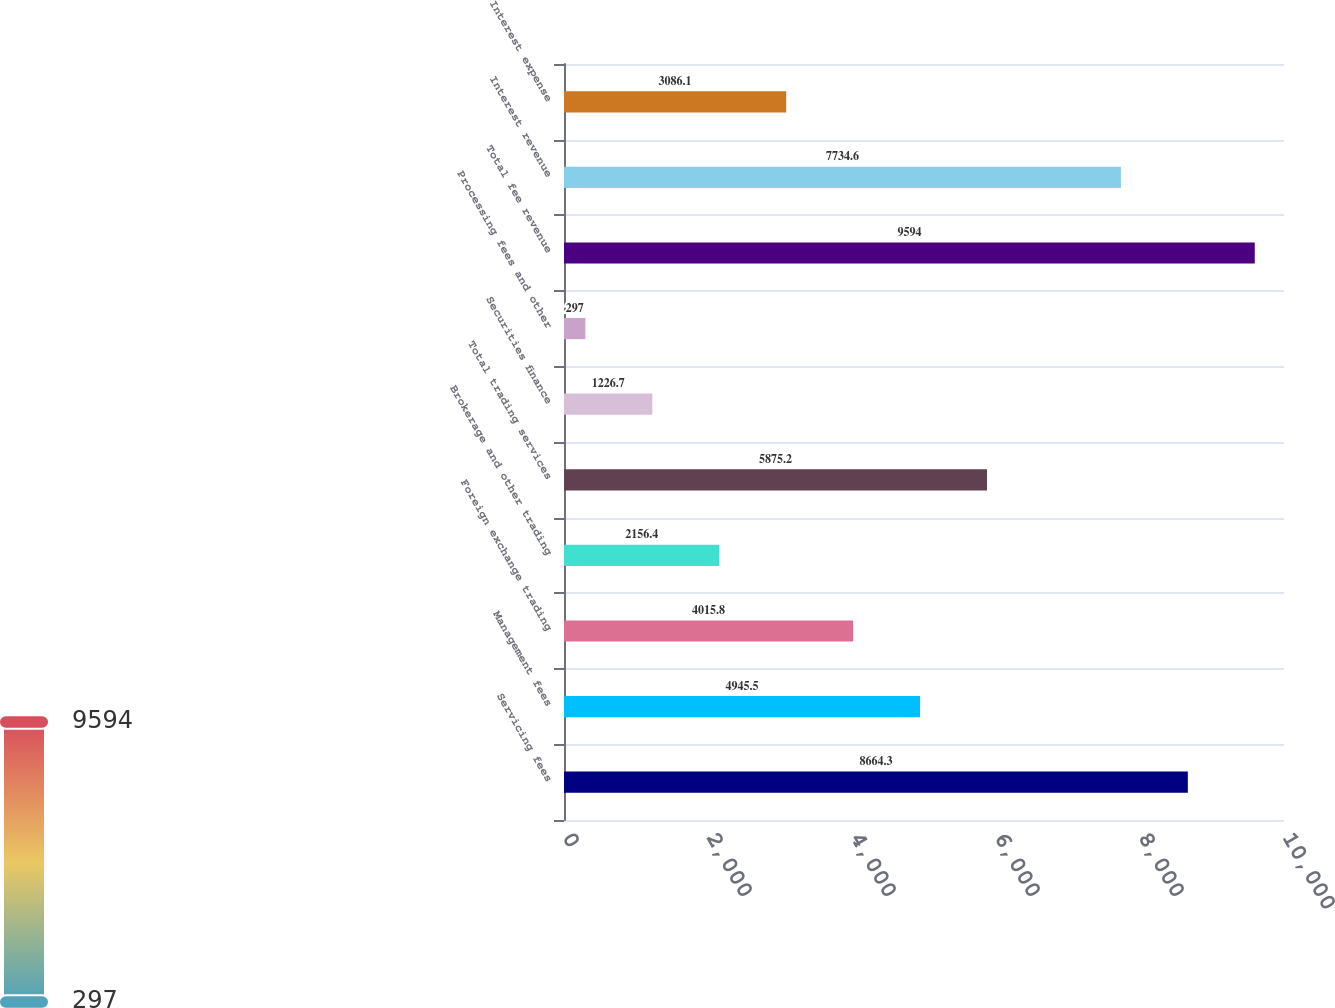Convert chart to OTSL. <chart><loc_0><loc_0><loc_500><loc_500><bar_chart><fcel>Servicing fees<fcel>Management fees<fcel>Foreign exchange trading<fcel>Brokerage and other trading<fcel>Total trading services<fcel>Securities finance<fcel>Processing fees and other<fcel>Total fee revenue<fcel>Interest revenue<fcel>Interest expense<nl><fcel>8664.3<fcel>4945.5<fcel>4015.8<fcel>2156.4<fcel>5875.2<fcel>1226.7<fcel>297<fcel>9594<fcel>7734.6<fcel>3086.1<nl></chart> 